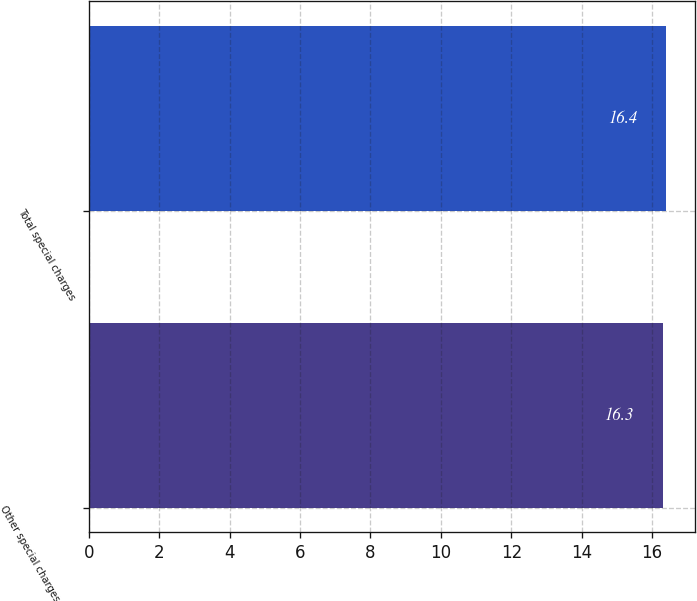<chart> <loc_0><loc_0><loc_500><loc_500><bar_chart><fcel>Other special charges in the<fcel>Total special charges<nl><fcel>16.3<fcel>16.4<nl></chart> 